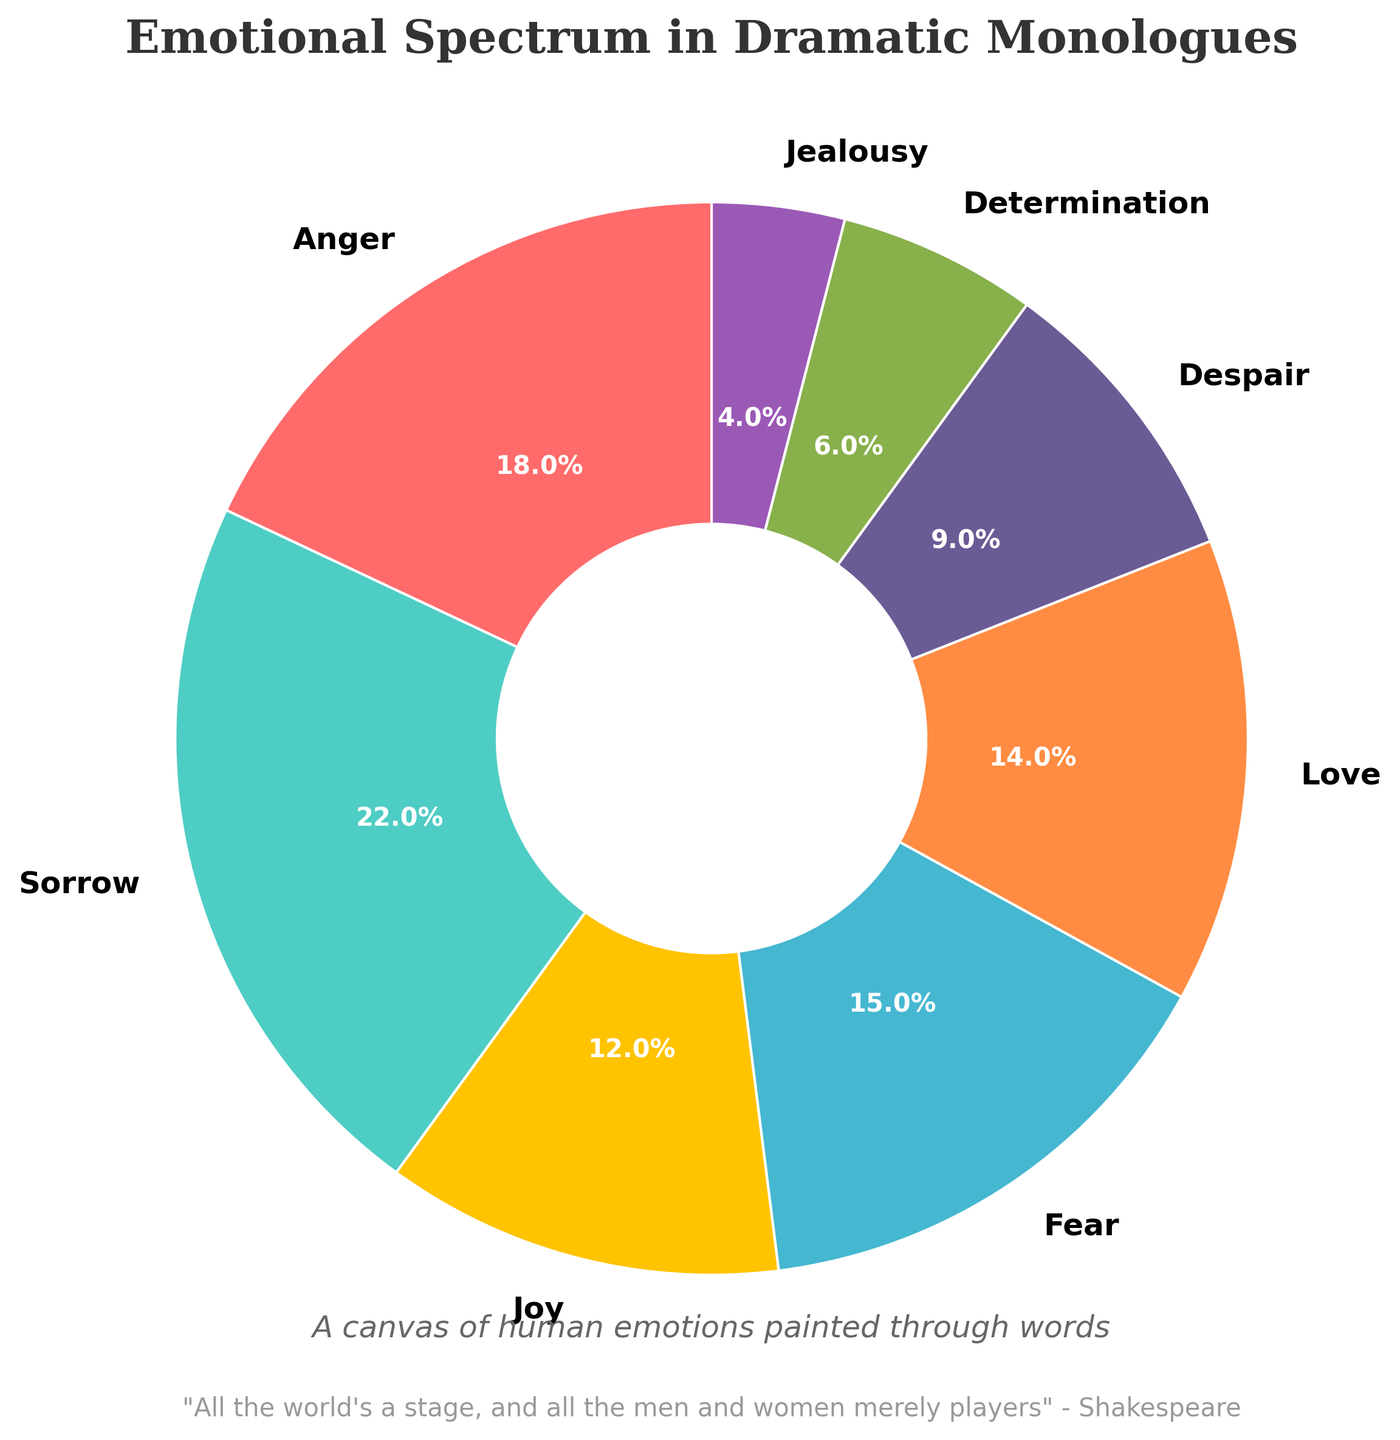Which emotion has the highest percentage in the pie chart? The figure shows a pie chart with emotional ranges and their corresponding percentages. The emotion with the highest percentage is "Sorrow" at 22%.
Answer: Sorrow Which emotion occupies the smallest slice of the pie chart? The figure shows that "Jealousy" occupies the smallest slice on the pie chart with a percentage of 4%.
Answer: Jealousy What is the combined percentage of Anger and Fear? Add the percentages of Anger (18%) and Fear (15%) from the pie chart. The combined percentage is 18 + 15 = 33%.
Answer: 33% Which two emotions together almost make up a third of the pie chart? By examining the pie chart, the combined percentage of Anger (18%) and Joy (12%) is 18 + 12 = 30%, which is almost a third of the pie chart (33.33%).
Answer: Anger and Joy Compare the percentages of Love and Determination. Which one is higher and by how much? Love has a percentage of 14% while Determination has 6%. The difference is 14 - 6 = 8%. So, Love is higher by 8%.
Answer: Love by 8% If you group "Sorrow", "Despair", and "Fear" together, what percentage of the pie chart do they cover? Add the percentages of Sorrow (22%), Despair (9%), and Fear (15%) from the pie chart. The total is 22 + 9 + 15 = 46%.
Answer: 46% How do the combined percentages of Joy and Love compare to the percentage of Sorrow? Joy and Love together make up 12% + 14% = 26%. Sorrow is 22%. Joy and Love combined (26%) are greater than Sorrow (22%).
Answer: Joy and Love are 4% greater than Sorrow What is the second most depicted emotion in the chart? The pie chart shows that after Sorrow (22%) the next highest percentage is Anger at 18%, making Anger the second most depicted emotion.
Answer: Anger Which emotions collectively contribute to less than a quarter of the pie chart? The sum of Determination (6%), Jealousy (4%), and Despair (9%) should be calculated: 6 + 4 + 9 = 19%. These emotions collectively contribute less than a quarter (25%).
Answer: Determination, Jealousy, and Despair Examine the color patterns in the pie chart; which emotion is depicted with a distinctive red color? The figure shows that the emotion Anger is depicted with a distinct red color.
Answer: Anger 